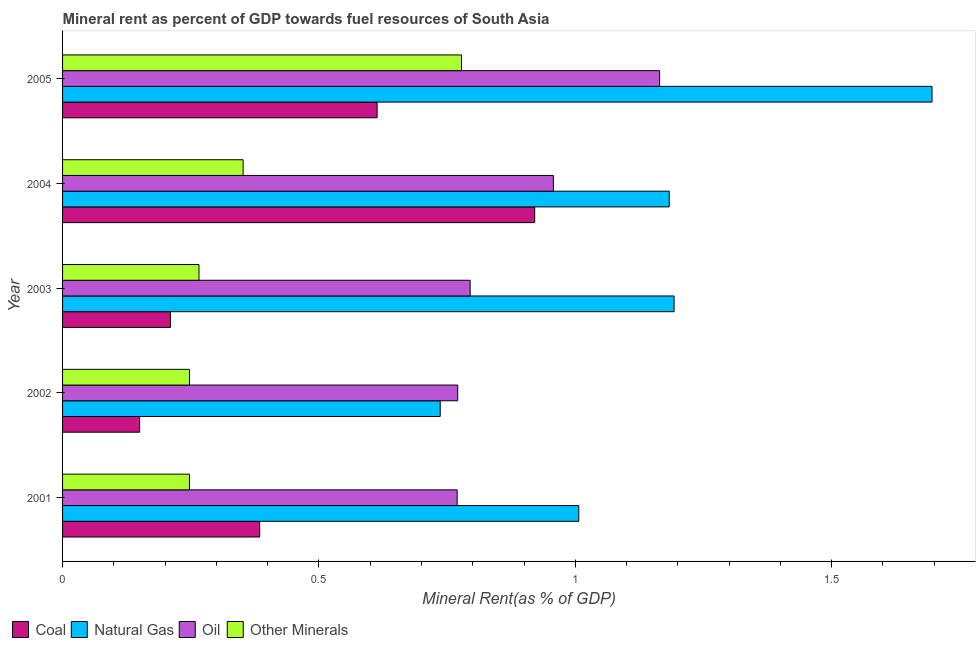Are the number of bars per tick equal to the number of legend labels?
Offer a terse response. Yes. Are the number of bars on each tick of the Y-axis equal?
Give a very brief answer. Yes. How many bars are there on the 2nd tick from the top?
Provide a short and direct response. 4. What is the oil rent in 2003?
Ensure brevity in your answer.  0.79. Across all years, what is the maximum oil rent?
Your answer should be compact. 1.16. Across all years, what is the minimum oil rent?
Provide a short and direct response. 0.77. In which year was the natural gas rent minimum?
Keep it short and to the point. 2002. What is the total  rent of other minerals in the graph?
Keep it short and to the point. 1.89. What is the difference between the  rent of other minerals in 2004 and that in 2005?
Provide a succinct answer. -0.43. What is the difference between the natural gas rent in 2001 and the coal rent in 2005?
Provide a succinct answer. 0.39. What is the average oil rent per year?
Your response must be concise. 0.89. In the year 2005, what is the difference between the coal rent and oil rent?
Give a very brief answer. -0.55. What is the ratio of the coal rent in 2001 to that in 2005?
Make the answer very short. 0.63. What is the difference between the highest and the second highest coal rent?
Make the answer very short. 0.31. What is the difference between the highest and the lowest oil rent?
Your answer should be compact. 0.39. What does the 3rd bar from the top in 2001 represents?
Your response must be concise. Natural Gas. What does the 1st bar from the bottom in 2001 represents?
Give a very brief answer. Coal. Are all the bars in the graph horizontal?
Give a very brief answer. Yes. How many years are there in the graph?
Ensure brevity in your answer.  5. Does the graph contain grids?
Provide a short and direct response. No. How are the legend labels stacked?
Keep it short and to the point. Horizontal. What is the title of the graph?
Your answer should be very brief. Mineral rent as percent of GDP towards fuel resources of South Asia. What is the label or title of the X-axis?
Keep it short and to the point. Mineral Rent(as % of GDP). What is the label or title of the Y-axis?
Give a very brief answer. Year. What is the Mineral Rent(as % of GDP) of Coal in 2001?
Provide a short and direct response. 0.38. What is the Mineral Rent(as % of GDP) in Natural Gas in 2001?
Your answer should be compact. 1.01. What is the Mineral Rent(as % of GDP) in Oil in 2001?
Make the answer very short. 0.77. What is the Mineral Rent(as % of GDP) of Other Minerals in 2001?
Make the answer very short. 0.25. What is the Mineral Rent(as % of GDP) of Coal in 2002?
Your response must be concise. 0.15. What is the Mineral Rent(as % of GDP) of Natural Gas in 2002?
Your answer should be very brief. 0.74. What is the Mineral Rent(as % of GDP) in Oil in 2002?
Offer a terse response. 0.77. What is the Mineral Rent(as % of GDP) in Other Minerals in 2002?
Provide a short and direct response. 0.25. What is the Mineral Rent(as % of GDP) in Coal in 2003?
Offer a very short reply. 0.21. What is the Mineral Rent(as % of GDP) in Natural Gas in 2003?
Your answer should be very brief. 1.19. What is the Mineral Rent(as % of GDP) in Oil in 2003?
Keep it short and to the point. 0.79. What is the Mineral Rent(as % of GDP) in Other Minerals in 2003?
Offer a terse response. 0.27. What is the Mineral Rent(as % of GDP) of Coal in 2004?
Provide a succinct answer. 0.92. What is the Mineral Rent(as % of GDP) in Natural Gas in 2004?
Provide a short and direct response. 1.18. What is the Mineral Rent(as % of GDP) in Oil in 2004?
Ensure brevity in your answer.  0.96. What is the Mineral Rent(as % of GDP) in Other Minerals in 2004?
Your answer should be very brief. 0.35. What is the Mineral Rent(as % of GDP) of Coal in 2005?
Provide a succinct answer. 0.61. What is the Mineral Rent(as % of GDP) of Natural Gas in 2005?
Provide a succinct answer. 1.7. What is the Mineral Rent(as % of GDP) of Oil in 2005?
Your answer should be compact. 1.16. What is the Mineral Rent(as % of GDP) of Other Minerals in 2005?
Ensure brevity in your answer.  0.78. Across all years, what is the maximum Mineral Rent(as % of GDP) in Coal?
Give a very brief answer. 0.92. Across all years, what is the maximum Mineral Rent(as % of GDP) in Natural Gas?
Offer a very short reply. 1.7. Across all years, what is the maximum Mineral Rent(as % of GDP) of Oil?
Your answer should be compact. 1.16. Across all years, what is the maximum Mineral Rent(as % of GDP) of Other Minerals?
Your answer should be very brief. 0.78. Across all years, what is the minimum Mineral Rent(as % of GDP) of Coal?
Keep it short and to the point. 0.15. Across all years, what is the minimum Mineral Rent(as % of GDP) of Natural Gas?
Keep it short and to the point. 0.74. Across all years, what is the minimum Mineral Rent(as % of GDP) in Oil?
Your answer should be compact. 0.77. Across all years, what is the minimum Mineral Rent(as % of GDP) of Other Minerals?
Keep it short and to the point. 0.25. What is the total Mineral Rent(as % of GDP) of Coal in the graph?
Provide a succinct answer. 2.28. What is the total Mineral Rent(as % of GDP) of Natural Gas in the graph?
Keep it short and to the point. 5.81. What is the total Mineral Rent(as % of GDP) of Oil in the graph?
Offer a terse response. 4.46. What is the total Mineral Rent(as % of GDP) in Other Minerals in the graph?
Provide a succinct answer. 1.89. What is the difference between the Mineral Rent(as % of GDP) of Coal in 2001 and that in 2002?
Your response must be concise. 0.23. What is the difference between the Mineral Rent(as % of GDP) of Natural Gas in 2001 and that in 2002?
Offer a terse response. 0.27. What is the difference between the Mineral Rent(as % of GDP) in Oil in 2001 and that in 2002?
Ensure brevity in your answer.  -0. What is the difference between the Mineral Rent(as % of GDP) in Other Minerals in 2001 and that in 2002?
Keep it short and to the point. -0. What is the difference between the Mineral Rent(as % of GDP) in Coal in 2001 and that in 2003?
Provide a succinct answer. 0.17. What is the difference between the Mineral Rent(as % of GDP) of Natural Gas in 2001 and that in 2003?
Your answer should be very brief. -0.19. What is the difference between the Mineral Rent(as % of GDP) of Oil in 2001 and that in 2003?
Offer a terse response. -0.03. What is the difference between the Mineral Rent(as % of GDP) of Other Minerals in 2001 and that in 2003?
Keep it short and to the point. -0.02. What is the difference between the Mineral Rent(as % of GDP) in Coal in 2001 and that in 2004?
Your response must be concise. -0.54. What is the difference between the Mineral Rent(as % of GDP) in Natural Gas in 2001 and that in 2004?
Your response must be concise. -0.18. What is the difference between the Mineral Rent(as % of GDP) of Oil in 2001 and that in 2004?
Provide a succinct answer. -0.19. What is the difference between the Mineral Rent(as % of GDP) of Other Minerals in 2001 and that in 2004?
Your answer should be very brief. -0.1. What is the difference between the Mineral Rent(as % of GDP) of Coal in 2001 and that in 2005?
Your response must be concise. -0.23. What is the difference between the Mineral Rent(as % of GDP) in Natural Gas in 2001 and that in 2005?
Offer a terse response. -0.69. What is the difference between the Mineral Rent(as % of GDP) in Oil in 2001 and that in 2005?
Offer a very short reply. -0.39. What is the difference between the Mineral Rent(as % of GDP) of Other Minerals in 2001 and that in 2005?
Offer a very short reply. -0.53. What is the difference between the Mineral Rent(as % of GDP) in Coal in 2002 and that in 2003?
Provide a succinct answer. -0.06. What is the difference between the Mineral Rent(as % of GDP) of Natural Gas in 2002 and that in 2003?
Offer a very short reply. -0.46. What is the difference between the Mineral Rent(as % of GDP) in Oil in 2002 and that in 2003?
Your response must be concise. -0.02. What is the difference between the Mineral Rent(as % of GDP) in Other Minerals in 2002 and that in 2003?
Keep it short and to the point. -0.02. What is the difference between the Mineral Rent(as % of GDP) in Coal in 2002 and that in 2004?
Your answer should be compact. -0.77. What is the difference between the Mineral Rent(as % of GDP) in Natural Gas in 2002 and that in 2004?
Make the answer very short. -0.45. What is the difference between the Mineral Rent(as % of GDP) of Oil in 2002 and that in 2004?
Your response must be concise. -0.19. What is the difference between the Mineral Rent(as % of GDP) of Other Minerals in 2002 and that in 2004?
Your answer should be compact. -0.1. What is the difference between the Mineral Rent(as % of GDP) in Coal in 2002 and that in 2005?
Offer a terse response. -0.46. What is the difference between the Mineral Rent(as % of GDP) in Natural Gas in 2002 and that in 2005?
Your response must be concise. -0.96. What is the difference between the Mineral Rent(as % of GDP) of Oil in 2002 and that in 2005?
Offer a terse response. -0.39. What is the difference between the Mineral Rent(as % of GDP) in Other Minerals in 2002 and that in 2005?
Give a very brief answer. -0.53. What is the difference between the Mineral Rent(as % of GDP) in Coal in 2003 and that in 2004?
Provide a short and direct response. -0.71. What is the difference between the Mineral Rent(as % of GDP) of Natural Gas in 2003 and that in 2004?
Offer a terse response. 0.01. What is the difference between the Mineral Rent(as % of GDP) of Oil in 2003 and that in 2004?
Offer a terse response. -0.16. What is the difference between the Mineral Rent(as % of GDP) in Other Minerals in 2003 and that in 2004?
Your answer should be very brief. -0.09. What is the difference between the Mineral Rent(as % of GDP) in Coal in 2003 and that in 2005?
Your answer should be compact. -0.4. What is the difference between the Mineral Rent(as % of GDP) in Natural Gas in 2003 and that in 2005?
Make the answer very short. -0.5. What is the difference between the Mineral Rent(as % of GDP) of Oil in 2003 and that in 2005?
Your answer should be very brief. -0.37. What is the difference between the Mineral Rent(as % of GDP) of Other Minerals in 2003 and that in 2005?
Keep it short and to the point. -0.51. What is the difference between the Mineral Rent(as % of GDP) in Coal in 2004 and that in 2005?
Offer a very short reply. 0.31. What is the difference between the Mineral Rent(as % of GDP) in Natural Gas in 2004 and that in 2005?
Provide a short and direct response. -0.51. What is the difference between the Mineral Rent(as % of GDP) in Oil in 2004 and that in 2005?
Your answer should be very brief. -0.21. What is the difference between the Mineral Rent(as % of GDP) of Other Minerals in 2004 and that in 2005?
Keep it short and to the point. -0.43. What is the difference between the Mineral Rent(as % of GDP) of Coal in 2001 and the Mineral Rent(as % of GDP) of Natural Gas in 2002?
Keep it short and to the point. -0.35. What is the difference between the Mineral Rent(as % of GDP) in Coal in 2001 and the Mineral Rent(as % of GDP) in Oil in 2002?
Offer a terse response. -0.39. What is the difference between the Mineral Rent(as % of GDP) of Coal in 2001 and the Mineral Rent(as % of GDP) of Other Minerals in 2002?
Your answer should be compact. 0.14. What is the difference between the Mineral Rent(as % of GDP) of Natural Gas in 2001 and the Mineral Rent(as % of GDP) of Oil in 2002?
Provide a succinct answer. 0.24. What is the difference between the Mineral Rent(as % of GDP) of Natural Gas in 2001 and the Mineral Rent(as % of GDP) of Other Minerals in 2002?
Give a very brief answer. 0.76. What is the difference between the Mineral Rent(as % of GDP) of Oil in 2001 and the Mineral Rent(as % of GDP) of Other Minerals in 2002?
Provide a succinct answer. 0.52. What is the difference between the Mineral Rent(as % of GDP) in Coal in 2001 and the Mineral Rent(as % of GDP) in Natural Gas in 2003?
Offer a very short reply. -0.81. What is the difference between the Mineral Rent(as % of GDP) of Coal in 2001 and the Mineral Rent(as % of GDP) of Oil in 2003?
Offer a very short reply. -0.41. What is the difference between the Mineral Rent(as % of GDP) of Coal in 2001 and the Mineral Rent(as % of GDP) of Other Minerals in 2003?
Keep it short and to the point. 0.12. What is the difference between the Mineral Rent(as % of GDP) in Natural Gas in 2001 and the Mineral Rent(as % of GDP) in Oil in 2003?
Your answer should be very brief. 0.21. What is the difference between the Mineral Rent(as % of GDP) of Natural Gas in 2001 and the Mineral Rent(as % of GDP) of Other Minerals in 2003?
Provide a succinct answer. 0.74. What is the difference between the Mineral Rent(as % of GDP) in Oil in 2001 and the Mineral Rent(as % of GDP) in Other Minerals in 2003?
Your answer should be compact. 0.5. What is the difference between the Mineral Rent(as % of GDP) in Coal in 2001 and the Mineral Rent(as % of GDP) in Natural Gas in 2004?
Your answer should be compact. -0.8. What is the difference between the Mineral Rent(as % of GDP) of Coal in 2001 and the Mineral Rent(as % of GDP) of Oil in 2004?
Provide a short and direct response. -0.57. What is the difference between the Mineral Rent(as % of GDP) in Coal in 2001 and the Mineral Rent(as % of GDP) in Other Minerals in 2004?
Your answer should be very brief. 0.03. What is the difference between the Mineral Rent(as % of GDP) in Natural Gas in 2001 and the Mineral Rent(as % of GDP) in Oil in 2004?
Provide a short and direct response. 0.05. What is the difference between the Mineral Rent(as % of GDP) in Natural Gas in 2001 and the Mineral Rent(as % of GDP) in Other Minerals in 2004?
Give a very brief answer. 0.65. What is the difference between the Mineral Rent(as % of GDP) in Oil in 2001 and the Mineral Rent(as % of GDP) in Other Minerals in 2004?
Keep it short and to the point. 0.42. What is the difference between the Mineral Rent(as % of GDP) of Coal in 2001 and the Mineral Rent(as % of GDP) of Natural Gas in 2005?
Offer a terse response. -1.31. What is the difference between the Mineral Rent(as % of GDP) of Coal in 2001 and the Mineral Rent(as % of GDP) of Oil in 2005?
Your response must be concise. -0.78. What is the difference between the Mineral Rent(as % of GDP) of Coal in 2001 and the Mineral Rent(as % of GDP) of Other Minerals in 2005?
Offer a terse response. -0.39. What is the difference between the Mineral Rent(as % of GDP) in Natural Gas in 2001 and the Mineral Rent(as % of GDP) in Oil in 2005?
Your answer should be compact. -0.16. What is the difference between the Mineral Rent(as % of GDP) in Natural Gas in 2001 and the Mineral Rent(as % of GDP) in Other Minerals in 2005?
Offer a terse response. 0.23. What is the difference between the Mineral Rent(as % of GDP) of Oil in 2001 and the Mineral Rent(as % of GDP) of Other Minerals in 2005?
Offer a very short reply. -0.01. What is the difference between the Mineral Rent(as % of GDP) of Coal in 2002 and the Mineral Rent(as % of GDP) of Natural Gas in 2003?
Keep it short and to the point. -1.04. What is the difference between the Mineral Rent(as % of GDP) in Coal in 2002 and the Mineral Rent(as % of GDP) in Oil in 2003?
Provide a short and direct response. -0.64. What is the difference between the Mineral Rent(as % of GDP) of Coal in 2002 and the Mineral Rent(as % of GDP) of Other Minerals in 2003?
Your response must be concise. -0.12. What is the difference between the Mineral Rent(as % of GDP) in Natural Gas in 2002 and the Mineral Rent(as % of GDP) in Oil in 2003?
Offer a terse response. -0.06. What is the difference between the Mineral Rent(as % of GDP) of Natural Gas in 2002 and the Mineral Rent(as % of GDP) of Other Minerals in 2003?
Keep it short and to the point. 0.47. What is the difference between the Mineral Rent(as % of GDP) of Oil in 2002 and the Mineral Rent(as % of GDP) of Other Minerals in 2003?
Provide a short and direct response. 0.5. What is the difference between the Mineral Rent(as % of GDP) in Coal in 2002 and the Mineral Rent(as % of GDP) in Natural Gas in 2004?
Ensure brevity in your answer.  -1.03. What is the difference between the Mineral Rent(as % of GDP) of Coal in 2002 and the Mineral Rent(as % of GDP) of Oil in 2004?
Provide a short and direct response. -0.81. What is the difference between the Mineral Rent(as % of GDP) in Coal in 2002 and the Mineral Rent(as % of GDP) in Other Minerals in 2004?
Ensure brevity in your answer.  -0.2. What is the difference between the Mineral Rent(as % of GDP) of Natural Gas in 2002 and the Mineral Rent(as % of GDP) of Oil in 2004?
Offer a very short reply. -0.22. What is the difference between the Mineral Rent(as % of GDP) in Natural Gas in 2002 and the Mineral Rent(as % of GDP) in Other Minerals in 2004?
Offer a very short reply. 0.38. What is the difference between the Mineral Rent(as % of GDP) of Oil in 2002 and the Mineral Rent(as % of GDP) of Other Minerals in 2004?
Provide a succinct answer. 0.42. What is the difference between the Mineral Rent(as % of GDP) in Coal in 2002 and the Mineral Rent(as % of GDP) in Natural Gas in 2005?
Your response must be concise. -1.55. What is the difference between the Mineral Rent(as % of GDP) of Coal in 2002 and the Mineral Rent(as % of GDP) of Oil in 2005?
Keep it short and to the point. -1.01. What is the difference between the Mineral Rent(as % of GDP) of Coal in 2002 and the Mineral Rent(as % of GDP) of Other Minerals in 2005?
Ensure brevity in your answer.  -0.63. What is the difference between the Mineral Rent(as % of GDP) in Natural Gas in 2002 and the Mineral Rent(as % of GDP) in Oil in 2005?
Ensure brevity in your answer.  -0.43. What is the difference between the Mineral Rent(as % of GDP) in Natural Gas in 2002 and the Mineral Rent(as % of GDP) in Other Minerals in 2005?
Your answer should be very brief. -0.04. What is the difference between the Mineral Rent(as % of GDP) of Oil in 2002 and the Mineral Rent(as % of GDP) of Other Minerals in 2005?
Keep it short and to the point. -0.01. What is the difference between the Mineral Rent(as % of GDP) in Coal in 2003 and the Mineral Rent(as % of GDP) in Natural Gas in 2004?
Give a very brief answer. -0.97. What is the difference between the Mineral Rent(as % of GDP) in Coal in 2003 and the Mineral Rent(as % of GDP) in Oil in 2004?
Provide a short and direct response. -0.75. What is the difference between the Mineral Rent(as % of GDP) of Coal in 2003 and the Mineral Rent(as % of GDP) of Other Minerals in 2004?
Offer a very short reply. -0.14. What is the difference between the Mineral Rent(as % of GDP) of Natural Gas in 2003 and the Mineral Rent(as % of GDP) of Oil in 2004?
Offer a very short reply. 0.24. What is the difference between the Mineral Rent(as % of GDP) of Natural Gas in 2003 and the Mineral Rent(as % of GDP) of Other Minerals in 2004?
Provide a succinct answer. 0.84. What is the difference between the Mineral Rent(as % of GDP) in Oil in 2003 and the Mineral Rent(as % of GDP) in Other Minerals in 2004?
Your response must be concise. 0.44. What is the difference between the Mineral Rent(as % of GDP) of Coal in 2003 and the Mineral Rent(as % of GDP) of Natural Gas in 2005?
Ensure brevity in your answer.  -1.49. What is the difference between the Mineral Rent(as % of GDP) of Coal in 2003 and the Mineral Rent(as % of GDP) of Oil in 2005?
Your response must be concise. -0.95. What is the difference between the Mineral Rent(as % of GDP) of Coal in 2003 and the Mineral Rent(as % of GDP) of Other Minerals in 2005?
Make the answer very short. -0.57. What is the difference between the Mineral Rent(as % of GDP) in Natural Gas in 2003 and the Mineral Rent(as % of GDP) in Oil in 2005?
Make the answer very short. 0.03. What is the difference between the Mineral Rent(as % of GDP) of Natural Gas in 2003 and the Mineral Rent(as % of GDP) of Other Minerals in 2005?
Keep it short and to the point. 0.41. What is the difference between the Mineral Rent(as % of GDP) in Oil in 2003 and the Mineral Rent(as % of GDP) in Other Minerals in 2005?
Make the answer very short. 0.02. What is the difference between the Mineral Rent(as % of GDP) of Coal in 2004 and the Mineral Rent(as % of GDP) of Natural Gas in 2005?
Keep it short and to the point. -0.77. What is the difference between the Mineral Rent(as % of GDP) of Coal in 2004 and the Mineral Rent(as % of GDP) of Oil in 2005?
Offer a terse response. -0.24. What is the difference between the Mineral Rent(as % of GDP) in Coal in 2004 and the Mineral Rent(as % of GDP) in Other Minerals in 2005?
Keep it short and to the point. 0.14. What is the difference between the Mineral Rent(as % of GDP) in Natural Gas in 2004 and the Mineral Rent(as % of GDP) in Oil in 2005?
Make the answer very short. 0.02. What is the difference between the Mineral Rent(as % of GDP) of Natural Gas in 2004 and the Mineral Rent(as % of GDP) of Other Minerals in 2005?
Offer a terse response. 0.41. What is the difference between the Mineral Rent(as % of GDP) of Oil in 2004 and the Mineral Rent(as % of GDP) of Other Minerals in 2005?
Offer a very short reply. 0.18. What is the average Mineral Rent(as % of GDP) of Coal per year?
Ensure brevity in your answer.  0.46. What is the average Mineral Rent(as % of GDP) of Natural Gas per year?
Your answer should be very brief. 1.16. What is the average Mineral Rent(as % of GDP) in Oil per year?
Your answer should be compact. 0.89. What is the average Mineral Rent(as % of GDP) of Other Minerals per year?
Your answer should be compact. 0.38. In the year 2001, what is the difference between the Mineral Rent(as % of GDP) in Coal and Mineral Rent(as % of GDP) in Natural Gas?
Offer a terse response. -0.62. In the year 2001, what is the difference between the Mineral Rent(as % of GDP) in Coal and Mineral Rent(as % of GDP) in Oil?
Give a very brief answer. -0.39. In the year 2001, what is the difference between the Mineral Rent(as % of GDP) of Coal and Mineral Rent(as % of GDP) of Other Minerals?
Offer a terse response. 0.14. In the year 2001, what is the difference between the Mineral Rent(as % of GDP) in Natural Gas and Mineral Rent(as % of GDP) in Oil?
Provide a short and direct response. 0.24. In the year 2001, what is the difference between the Mineral Rent(as % of GDP) in Natural Gas and Mineral Rent(as % of GDP) in Other Minerals?
Offer a very short reply. 0.76. In the year 2001, what is the difference between the Mineral Rent(as % of GDP) in Oil and Mineral Rent(as % of GDP) in Other Minerals?
Offer a terse response. 0.52. In the year 2002, what is the difference between the Mineral Rent(as % of GDP) of Coal and Mineral Rent(as % of GDP) of Natural Gas?
Provide a short and direct response. -0.59. In the year 2002, what is the difference between the Mineral Rent(as % of GDP) in Coal and Mineral Rent(as % of GDP) in Oil?
Your answer should be compact. -0.62. In the year 2002, what is the difference between the Mineral Rent(as % of GDP) of Coal and Mineral Rent(as % of GDP) of Other Minerals?
Give a very brief answer. -0.1. In the year 2002, what is the difference between the Mineral Rent(as % of GDP) of Natural Gas and Mineral Rent(as % of GDP) of Oil?
Your answer should be compact. -0.03. In the year 2002, what is the difference between the Mineral Rent(as % of GDP) in Natural Gas and Mineral Rent(as % of GDP) in Other Minerals?
Give a very brief answer. 0.49. In the year 2002, what is the difference between the Mineral Rent(as % of GDP) of Oil and Mineral Rent(as % of GDP) of Other Minerals?
Your answer should be very brief. 0.52. In the year 2003, what is the difference between the Mineral Rent(as % of GDP) of Coal and Mineral Rent(as % of GDP) of Natural Gas?
Ensure brevity in your answer.  -0.98. In the year 2003, what is the difference between the Mineral Rent(as % of GDP) of Coal and Mineral Rent(as % of GDP) of Oil?
Offer a very short reply. -0.58. In the year 2003, what is the difference between the Mineral Rent(as % of GDP) in Coal and Mineral Rent(as % of GDP) in Other Minerals?
Ensure brevity in your answer.  -0.06. In the year 2003, what is the difference between the Mineral Rent(as % of GDP) of Natural Gas and Mineral Rent(as % of GDP) of Oil?
Provide a short and direct response. 0.4. In the year 2003, what is the difference between the Mineral Rent(as % of GDP) in Natural Gas and Mineral Rent(as % of GDP) in Other Minerals?
Keep it short and to the point. 0.93. In the year 2003, what is the difference between the Mineral Rent(as % of GDP) in Oil and Mineral Rent(as % of GDP) in Other Minerals?
Make the answer very short. 0.53. In the year 2004, what is the difference between the Mineral Rent(as % of GDP) in Coal and Mineral Rent(as % of GDP) in Natural Gas?
Offer a very short reply. -0.26. In the year 2004, what is the difference between the Mineral Rent(as % of GDP) of Coal and Mineral Rent(as % of GDP) of Oil?
Provide a succinct answer. -0.04. In the year 2004, what is the difference between the Mineral Rent(as % of GDP) of Coal and Mineral Rent(as % of GDP) of Other Minerals?
Your answer should be compact. 0.57. In the year 2004, what is the difference between the Mineral Rent(as % of GDP) of Natural Gas and Mineral Rent(as % of GDP) of Oil?
Offer a terse response. 0.23. In the year 2004, what is the difference between the Mineral Rent(as % of GDP) of Natural Gas and Mineral Rent(as % of GDP) of Other Minerals?
Offer a very short reply. 0.83. In the year 2004, what is the difference between the Mineral Rent(as % of GDP) of Oil and Mineral Rent(as % of GDP) of Other Minerals?
Your answer should be compact. 0.61. In the year 2005, what is the difference between the Mineral Rent(as % of GDP) of Coal and Mineral Rent(as % of GDP) of Natural Gas?
Provide a succinct answer. -1.08. In the year 2005, what is the difference between the Mineral Rent(as % of GDP) in Coal and Mineral Rent(as % of GDP) in Oil?
Give a very brief answer. -0.55. In the year 2005, what is the difference between the Mineral Rent(as % of GDP) in Coal and Mineral Rent(as % of GDP) in Other Minerals?
Provide a short and direct response. -0.16. In the year 2005, what is the difference between the Mineral Rent(as % of GDP) of Natural Gas and Mineral Rent(as % of GDP) of Oil?
Provide a succinct answer. 0.53. In the year 2005, what is the difference between the Mineral Rent(as % of GDP) in Natural Gas and Mineral Rent(as % of GDP) in Other Minerals?
Offer a very short reply. 0.92. In the year 2005, what is the difference between the Mineral Rent(as % of GDP) in Oil and Mineral Rent(as % of GDP) in Other Minerals?
Keep it short and to the point. 0.39. What is the ratio of the Mineral Rent(as % of GDP) of Coal in 2001 to that in 2002?
Offer a very short reply. 2.56. What is the ratio of the Mineral Rent(as % of GDP) in Natural Gas in 2001 to that in 2002?
Make the answer very short. 1.37. What is the ratio of the Mineral Rent(as % of GDP) in Oil in 2001 to that in 2002?
Your response must be concise. 1. What is the ratio of the Mineral Rent(as % of GDP) of Other Minerals in 2001 to that in 2002?
Offer a very short reply. 1. What is the ratio of the Mineral Rent(as % of GDP) of Coal in 2001 to that in 2003?
Provide a short and direct response. 1.83. What is the ratio of the Mineral Rent(as % of GDP) in Natural Gas in 2001 to that in 2003?
Your response must be concise. 0.84. What is the ratio of the Mineral Rent(as % of GDP) of Oil in 2001 to that in 2003?
Ensure brevity in your answer.  0.97. What is the ratio of the Mineral Rent(as % of GDP) of Other Minerals in 2001 to that in 2003?
Keep it short and to the point. 0.93. What is the ratio of the Mineral Rent(as % of GDP) in Coal in 2001 to that in 2004?
Offer a very short reply. 0.42. What is the ratio of the Mineral Rent(as % of GDP) in Natural Gas in 2001 to that in 2004?
Keep it short and to the point. 0.85. What is the ratio of the Mineral Rent(as % of GDP) in Oil in 2001 to that in 2004?
Your answer should be very brief. 0.8. What is the ratio of the Mineral Rent(as % of GDP) of Other Minerals in 2001 to that in 2004?
Offer a terse response. 0.7. What is the ratio of the Mineral Rent(as % of GDP) in Coal in 2001 to that in 2005?
Offer a very short reply. 0.63. What is the ratio of the Mineral Rent(as % of GDP) in Natural Gas in 2001 to that in 2005?
Keep it short and to the point. 0.59. What is the ratio of the Mineral Rent(as % of GDP) of Oil in 2001 to that in 2005?
Your response must be concise. 0.66. What is the ratio of the Mineral Rent(as % of GDP) of Other Minerals in 2001 to that in 2005?
Make the answer very short. 0.32. What is the ratio of the Mineral Rent(as % of GDP) in Coal in 2002 to that in 2003?
Give a very brief answer. 0.71. What is the ratio of the Mineral Rent(as % of GDP) of Natural Gas in 2002 to that in 2003?
Provide a succinct answer. 0.62. What is the ratio of the Mineral Rent(as % of GDP) of Oil in 2002 to that in 2003?
Provide a succinct answer. 0.97. What is the ratio of the Mineral Rent(as % of GDP) of Other Minerals in 2002 to that in 2003?
Ensure brevity in your answer.  0.93. What is the ratio of the Mineral Rent(as % of GDP) of Coal in 2002 to that in 2004?
Your answer should be compact. 0.16. What is the ratio of the Mineral Rent(as % of GDP) in Natural Gas in 2002 to that in 2004?
Your answer should be very brief. 0.62. What is the ratio of the Mineral Rent(as % of GDP) of Oil in 2002 to that in 2004?
Provide a succinct answer. 0.81. What is the ratio of the Mineral Rent(as % of GDP) of Other Minerals in 2002 to that in 2004?
Keep it short and to the point. 0.7. What is the ratio of the Mineral Rent(as % of GDP) in Coal in 2002 to that in 2005?
Your answer should be compact. 0.24. What is the ratio of the Mineral Rent(as % of GDP) of Natural Gas in 2002 to that in 2005?
Your answer should be compact. 0.43. What is the ratio of the Mineral Rent(as % of GDP) in Oil in 2002 to that in 2005?
Make the answer very short. 0.66. What is the ratio of the Mineral Rent(as % of GDP) in Other Minerals in 2002 to that in 2005?
Keep it short and to the point. 0.32. What is the ratio of the Mineral Rent(as % of GDP) in Coal in 2003 to that in 2004?
Your response must be concise. 0.23. What is the ratio of the Mineral Rent(as % of GDP) of Natural Gas in 2003 to that in 2004?
Make the answer very short. 1.01. What is the ratio of the Mineral Rent(as % of GDP) of Oil in 2003 to that in 2004?
Provide a short and direct response. 0.83. What is the ratio of the Mineral Rent(as % of GDP) of Other Minerals in 2003 to that in 2004?
Your answer should be very brief. 0.76. What is the ratio of the Mineral Rent(as % of GDP) in Coal in 2003 to that in 2005?
Ensure brevity in your answer.  0.34. What is the ratio of the Mineral Rent(as % of GDP) of Natural Gas in 2003 to that in 2005?
Offer a very short reply. 0.7. What is the ratio of the Mineral Rent(as % of GDP) in Oil in 2003 to that in 2005?
Offer a very short reply. 0.68. What is the ratio of the Mineral Rent(as % of GDP) of Other Minerals in 2003 to that in 2005?
Your answer should be very brief. 0.34. What is the ratio of the Mineral Rent(as % of GDP) of Coal in 2004 to that in 2005?
Offer a very short reply. 1.5. What is the ratio of the Mineral Rent(as % of GDP) of Natural Gas in 2004 to that in 2005?
Your response must be concise. 0.7. What is the ratio of the Mineral Rent(as % of GDP) of Oil in 2004 to that in 2005?
Ensure brevity in your answer.  0.82. What is the ratio of the Mineral Rent(as % of GDP) of Other Minerals in 2004 to that in 2005?
Offer a terse response. 0.45. What is the difference between the highest and the second highest Mineral Rent(as % of GDP) of Coal?
Give a very brief answer. 0.31. What is the difference between the highest and the second highest Mineral Rent(as % of GDP) in Natural Gas?
Offer a very short reply. 0.5. What is the difference between the highest and the second highest Mineral Rent(as % of GDP) in Oil?
Provide a succinct answer. 0.21. What is the difference between the highest and the second highest Mineral Rent(as % of GDP) in Other Minerals?
Offer a very short reply. 0.43. What is the difference between the highest and the lowest Mineral Rent(as % of GDP) of Coal?
Your response must be concise. 0.77. What is the difference between the highest and the lowest Mineral Rent(as % of GDP) of Natural Gas?
Keep it short and to the point. 0.96. What is the difference between the highest and the lowest Mineral Rent(as % of GDP) in Oil?
Your answer should be very brief. 0.39. What is the difference between the highest and the lowest Mineral Rent(as % of GDP) of Other Minerals?
Your answer should be compact. 0.53. 